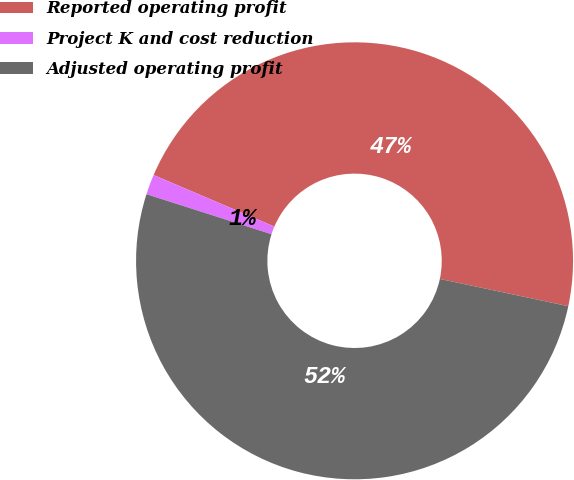Convert chart to OTSL. <chart><loc_0><loc_0><loc_500><loc_500><pie_chart><fcel>Reported operating profit<fcel>Project K and cost reduction<fcel>Adjusted operating profit<nl><fcel>46.91%<fcel>1.49%<fcel>51.6%<nl></chart> 